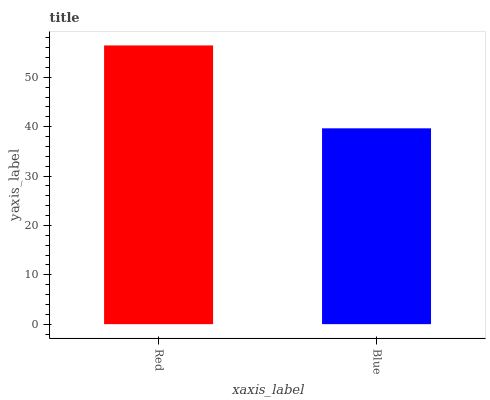Is Blue the maximum?
Answer yes or no. No. Is Red greater than Blue?
Answer yes or no. Yes. Is Blue less than Red?
Answer yes or no. Yes. Is Blue greater than Red?
Answer yes or no. No. Is Red less than Blue?
Answer yes or no. No. Is Red the high median?
Answer yes or no. Yes. Is Blue the low median?
Answer yes or no. Yes. Is Blue the high median?
Answer yes or no. No. Is Red the low median?
Answer yes or no. No. 